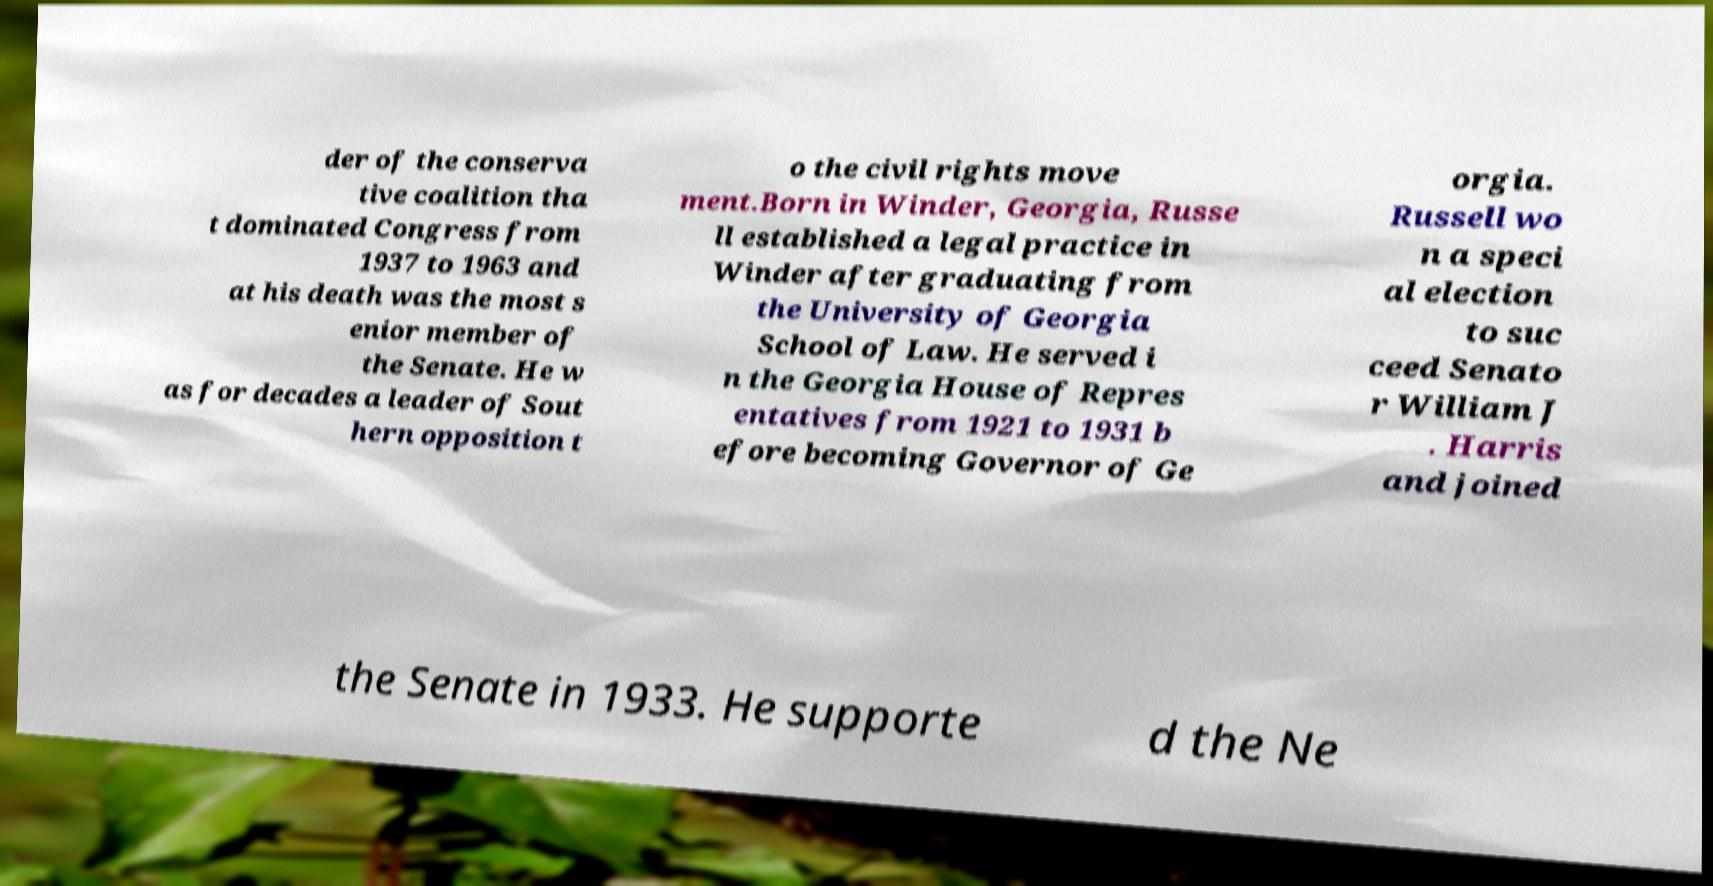Could you assist in decoding the text presented in this image and type it out clearly? der of the conserva tive coalition tha t dominated Congress from 1937 to 1963 and at his death was the most s enior member of the Senate. He w as for decades a leader of Sout hern opposition t o the civil rights move ment.Born in Winder, Georgia, Russe ll established a legal practice in Winder after graduating from the University of Georgia School of Law. He served i n the Georgia House of Repres entatives from 1921 to 1931 b efore becoming Governor of Ge orgia. Russell wo n a speci al election to suc ceed Senato r William J . Harris and joined the Senate in 1933. He supporte d the Ne 